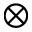Convert formula to latex. <formula><loc_0><loc_0><loc_500><loc_500>\otimes</formula> 